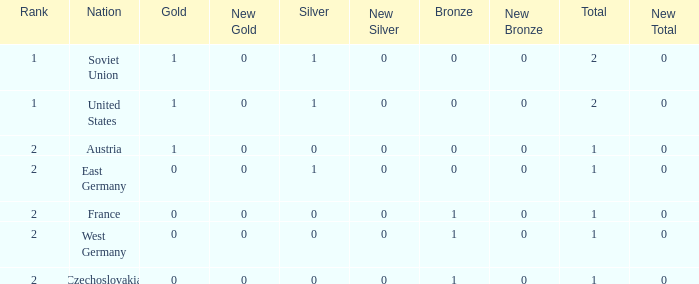What is the rank of the team with 0 gold and less than 0 silvers? None. 